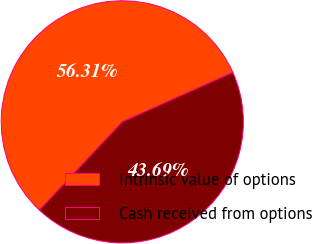Convert chart to OTSL. <chart><loc_0><loc_0><loc_500><loc_500><pie_chart><fcel>Intrinsic value of options<fcel>Cash received from options<nl><fcel>56.31%<fcel>43.69%<nl></chart> 